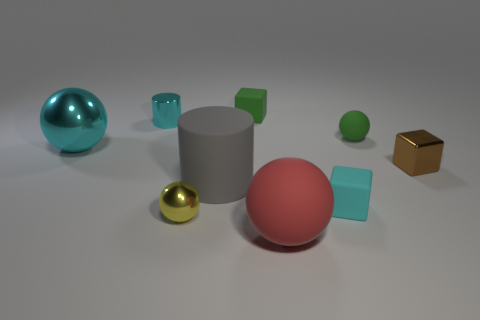The rubber thing that is behind the green object that is in front of the small cyan metal object to the left of the small brown thing is what shape?
Provide a succinct answer. Cube. There is a metal thing that is the same color as the large metal ball; what is its shape?
Your answer should be very brief. Cylinder. What material is the sphere that is in front of the small rubber ball and on the right side of the gray cylinder?
Make the answer very short. Rubber. Are there fewer large metallic balls than cubes?
Provide a succinct answer. Yes. Do the small cyan shiny object and the small shiny thing that is on the right side of the big gray object have the same shape?
Provide a short and direct response. No. Is the size of the matte sphere on the right side of the red thing the same as the large gray cylinder?
Make the answer very short. No. There is a brown shiny object that is the same size as the shiny cylinder; what is its shape?
Your response must be concise. Cube. Does the small cyan rubber thing have the same shape as the tiny yellow thing?
Keep it short and to the point. No. What number of other tiny objects are the same shape as the small brown shiny object?
Your response must be concise. 2. How many gray matte cylinders are right of the shiny cylinder?
Your answer should be very brief. 1. 